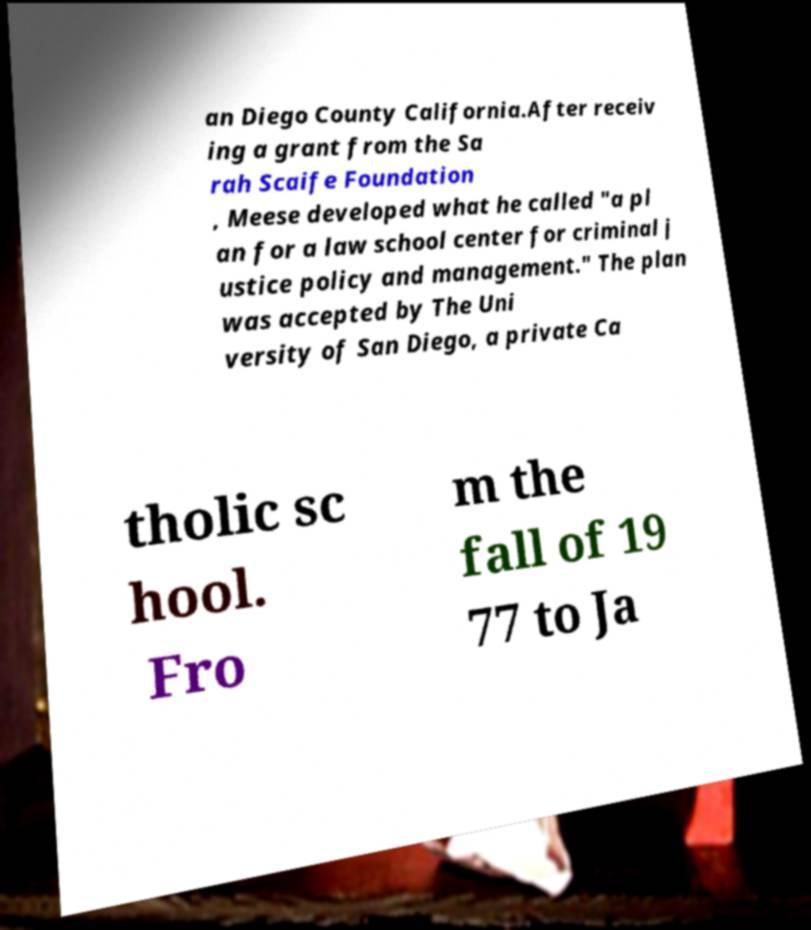I need the written content from this picture converted into text. Can you do that? an Diego County California.After receiv ing a grant from the Sa rah Scaife Foundation , Meese developed what he called "a pl an for a law school center for criminal j ustice policy and management." The plan was accepted by The Uni versity of San Diego, a private Ca tholic sc hool. Fro m the fall of 19 77 to Ja 